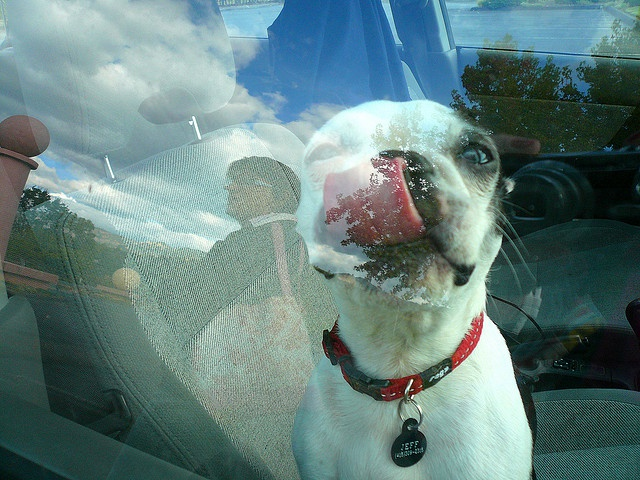Describe the objects in this image and their specific colors. I can see dog in lightblue, ivory, darkgray, teal, and gray tones, people in lightblue, darkgray, gray, and teal tones, and handbag in lightblue, darkgray, gray, and lightgray tones in this image. 